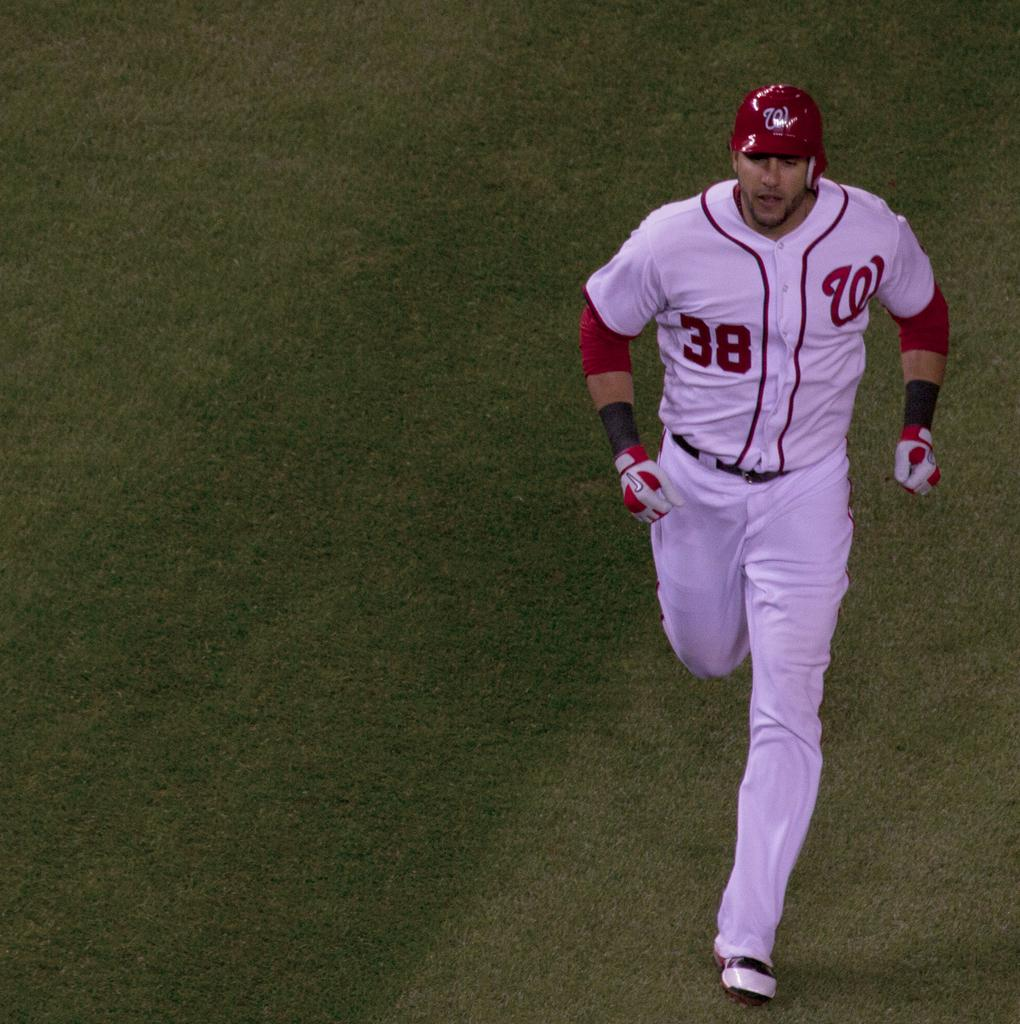<image>
Describe the image concisely. A baseball player wearing a uniform with number 38 on it. 